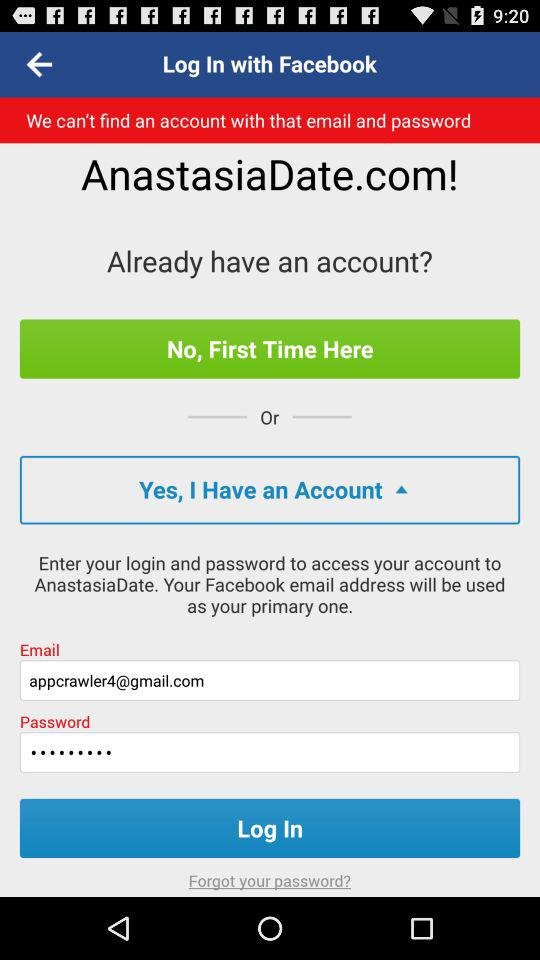What is the name of the application? The name of the application is "AnastasiaDate". 